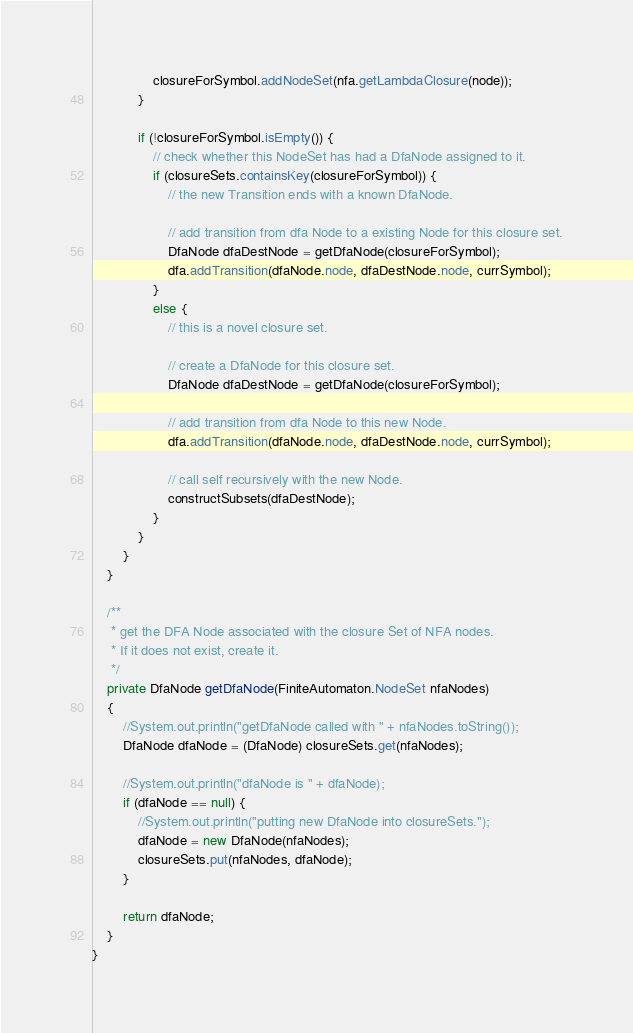<code> <loc_0><loc_0><loc_500><loc_500><_Java_>                closureForSymbol.addNodeSet(nfa.getLambdaClosure(node));
            }

            if (!closureForSymbol.isEmpty()) {
                // check whether this NodeSet has had a DfaNode assigned to it.
                if (closureSets.containsKey(closureForSymbol)) {
                    // the new Transition ends with a known DfaNode.

                    // add transition from dfa Node to a existing Node for this closure set.
                    DfaNode dfaDestNode = getDfaNode(closureForSymbol);
                    dfa.addTransition(dfaNode.node, dfaDestNode.node, currSymbol);
                }
                else {
                    // this is a novel closure set.

                    // create a DfaNode for this closure set.
                    DfaNode dfaDestNode = getDfaNode(closureForSymbol);

                    // add transition from dfa Node to this new Node.
                    dfa.addTransition(dfaNode.node, dfaDestNode.node, currSymbol);

                    // call self recursively with the new Node.
                    constructSubsets(dfaDestNode);
                }
            }
        }
    }

    /**
     * get the DFA Node associated with the closure Set of NFA nodes.
     * If it does not exist, create it.
     */
    private DfaNode getDfaNode(FiniteAutomaton.NodeSet nfaNodes)
    {
        //System.out.println("getDfaNode called with " + nfaNodes.toString());
        DfaNode dfaNode = (DfaNode) closureSets.get(nfaNodes);

        //System.out.println("dfaNode is " + dfaNode);
        if (dfaNode == null) {
            //System.out.println("putting new DfaNode into closureSets.");
            dfaNode = new DfaNode(nfaNodes);
            closureSets.put(nfaNodes, dfaNode);
        }

        return dfaNode;
    }
}
</code> 